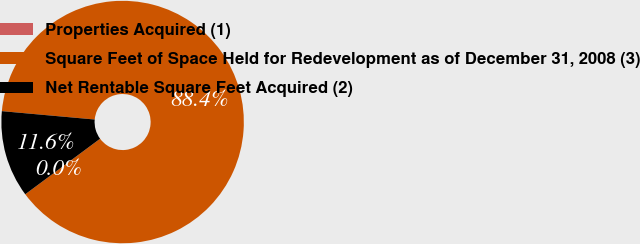<chart> <loc_0><loc_0><loc_500><loc_500><pie_chart><fcel>Properties Acquired (1)<fcel>Square Feet of Space Held for Redevelopment as of December 31, 2008 (3)<fcel>Net Rentable Square Feet Acquired (2)<nl><fcel>0.0%<fcel>88.41%<fcel>11.59%<nl></chart> 